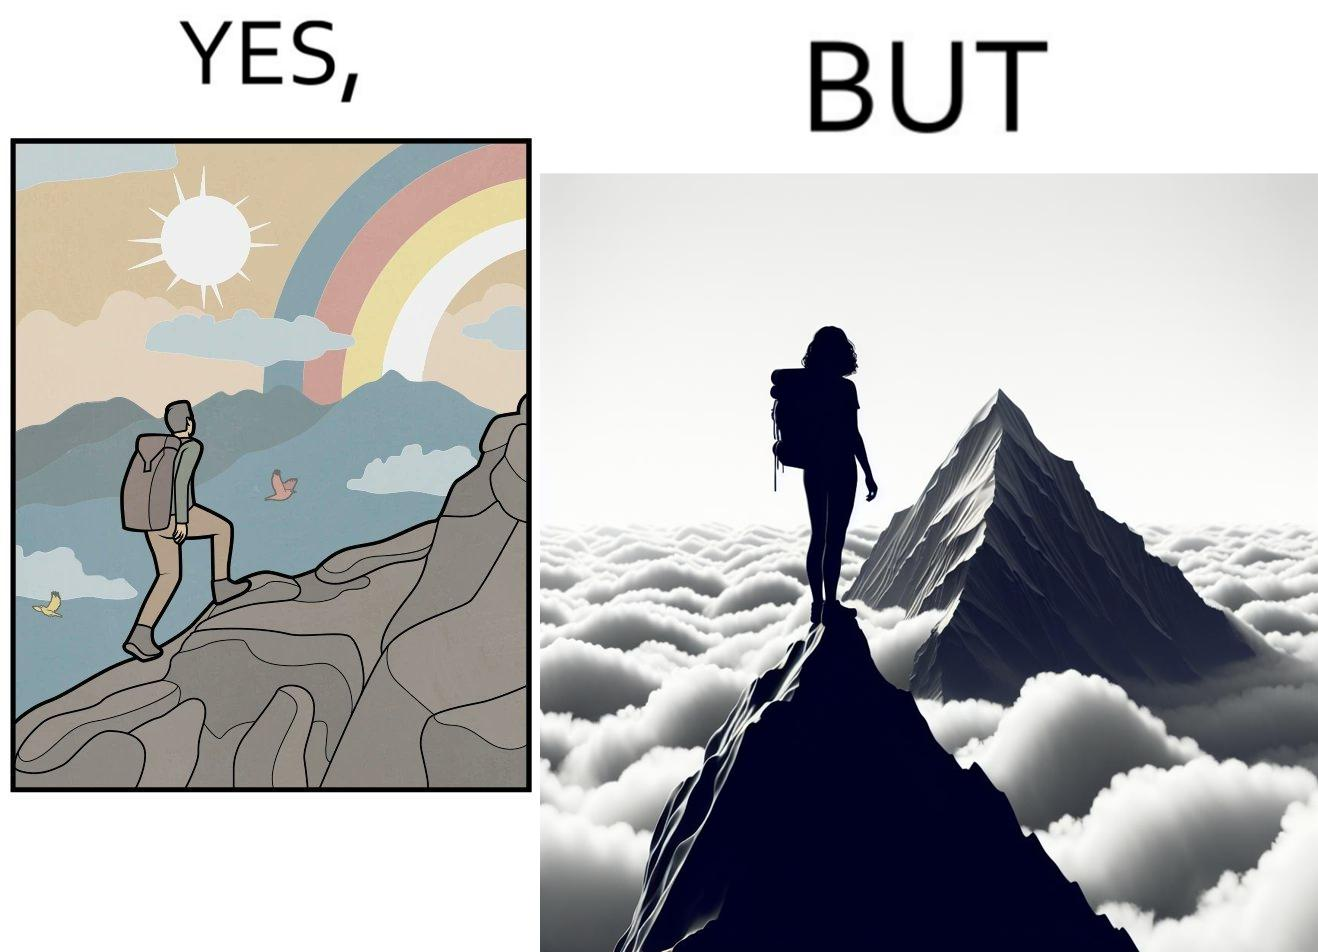What is the satirical meaning behind this image? The image is ironic, because the mountaineer climbs up the mountain to view the world from the peak but due to so much cloud, at the top, nothing is visible whereas he was able to witness some awesome views while climbing up the mountain 